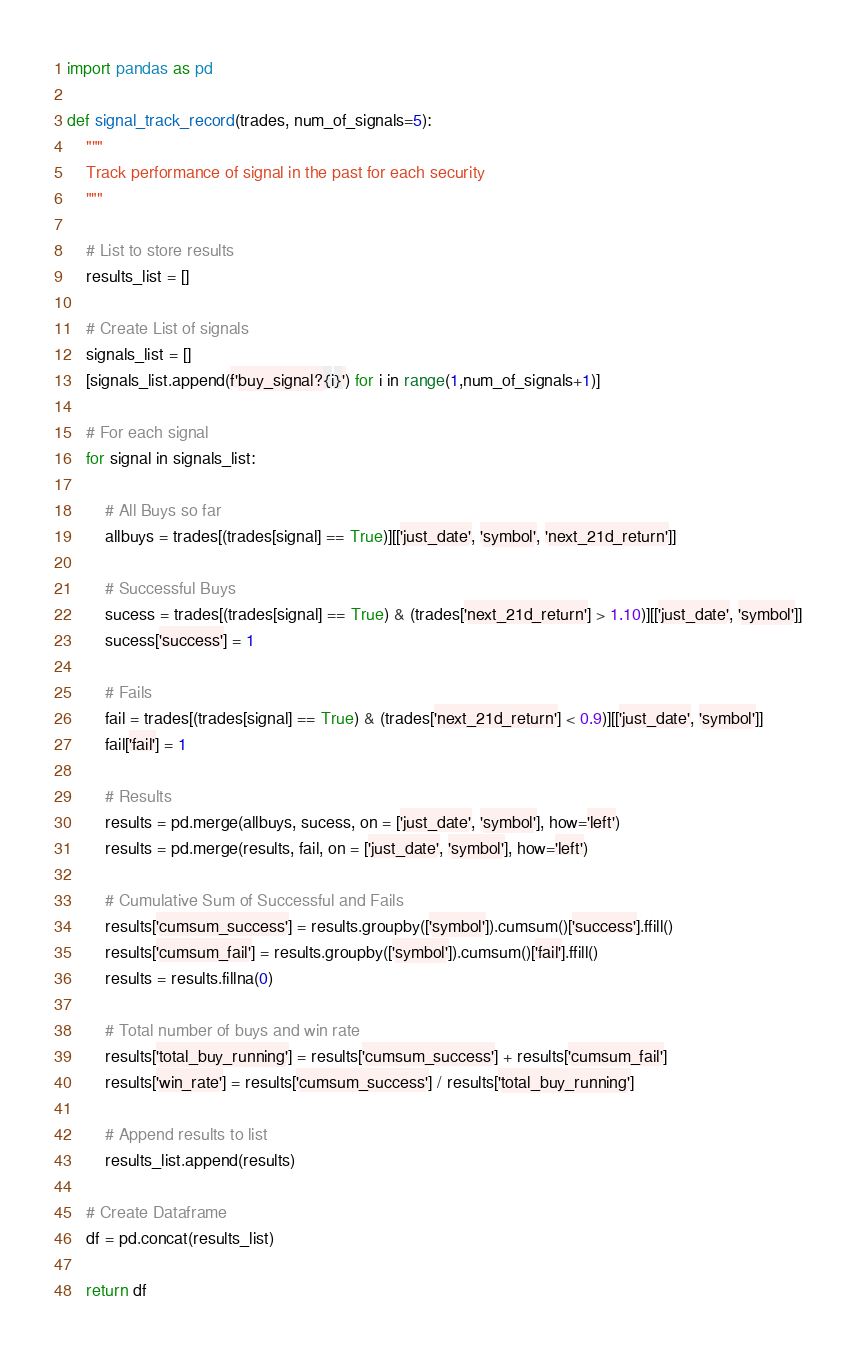<code> <loc_0><loc_0><loc_500><loc_500><_Python_>import pandas as pd

def signal_track_record(trades, num_of_signals=5):
    """
    Track performance of signal in the past for each security
    """

    # List to store results
    results_list = []

    # Create List of signals
    signals_list = []
    [signals_list.append(f'buy_signal?{i}') for i in range(1,num_of_signals+1)]

    # For each signal
    for signal in signals_list:

        # All Buys so far
        allbuys = trades[(trades[signal] == True)][['just_date', 'symbol', 'next_21d_return']]

        # Successful Buys
        sucess = trades[(trades[signal] == True) & (trades['next_21d_return'] > 1.10)][['just_date', 'symbol']]
        sucess['success'] = 1

        # Fails
        fail = trades[(trades[signal] == True) & (trades['next_21d_return'] < 0.9)][['just_date', 'symbol']]
        fail['fail'] = 1

        # Results
        results = pd.merge(allbuys, sucess, on = ['just_date', 'symbol'], how='left')
        results = pd.merge(results, fail, on = ['just_date', 'symbol'], how='left')

        # Cumulative Sum of Successful and Fails
        results['cumsum_success'] = results.groupby(['symbol']).cumsum()['success'].ffill()
        results['cumsum_fail'] = results.groupby(['symbol']).cumsum()['fail'].ffill()
        results = results.fillna(0)

        # Total number of buys and win rate
        results['total_buy_running'] = results['cumsum_success'] + results['cumsum_fail']
        results['win_rate'] = results['cumsum_success'] / results['total_buy_running']

        # Append results to list
        results_list.append(results)

    # Create Dataframe
    df = pd.concat(results_list)

    return df
</code> 